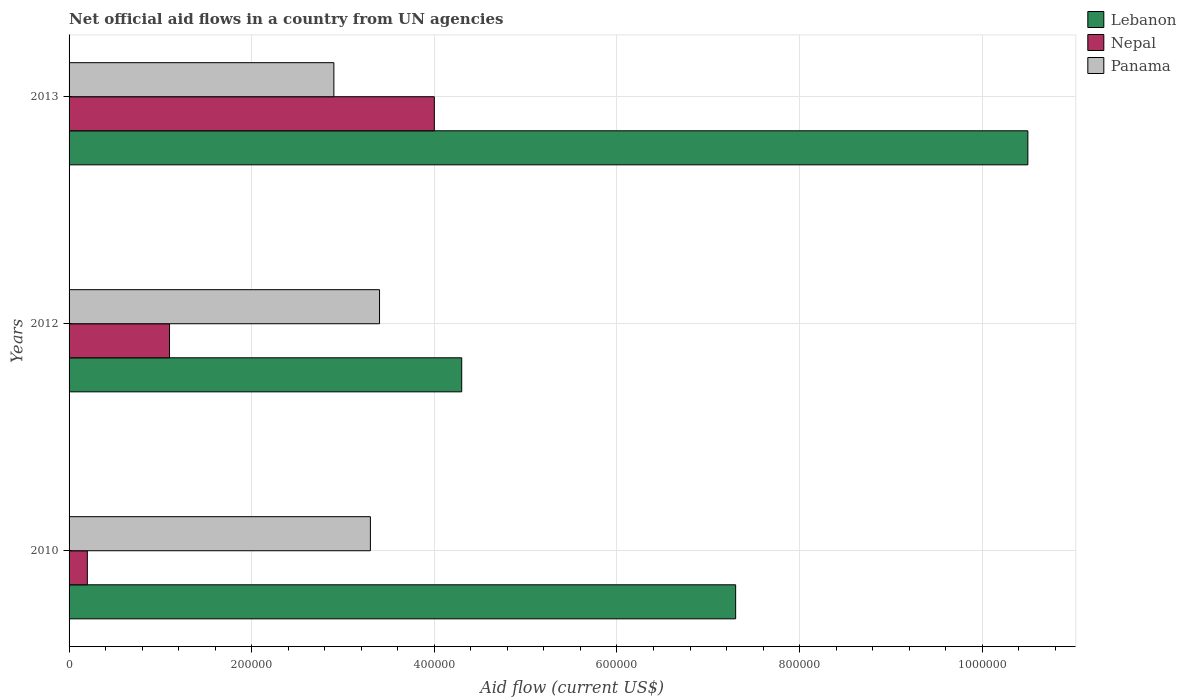How many groups of bars are there?
Give a very brief answer. 3. Are the number of bars per tick equal to the number of legend labels?
Your answer should be compact. Yes. How many bars are there on the 2nd tick from the bottom?
Offer a terse response. 3. What is the label of the 1st group of bars from the top?
Provide a short and direct response. 2013. Across all years, what is the maximum net official aid flow in Panama?
Provide a short and direct response. 3.40e+05. In which year was the net official aid flow in Nepal minimum?
Offer a terse response. 2010. What is the total net official aid flow in Nepal in the graph?
Ensure brevity in your answer.  5.30e+05. What is the difference between the net official aid flow in Panama in 2010 and that in 2012?
Provide a succinct answer. -10000. What is the difference between the net official aid flow in Nepal in 2010 and the net official aid flow in Lebanon in 2012?
Make the answer very short. -4.10e+05. What is the average net official aid flow in Nepal per year?
Provide a short and direct response. 1.77e+05. In the year 2013, what is the difference between the net official aid flow in Nepal and net official aid flow in Lebanon?
Your answer should be very brief. -6.50e+05. What is the ratio of the net official aid flow in Lebanon in 2010 to that in 2013?
Keep it short and to the point. 0.7. Is the difference between the net official aid flow in Nepal in 2010 and 2012 greater than the difference between the net official aid flow in Lebanon in 2010 and 2012?
Your response must be concise. No. What is the difference between the highest and the second highest net official aid flow in Lebanon?
Offer a very short reply. 3.20e+05. In how many years, is the net official aid flow in Panama greater than the average net official aid flow in Panama taken over all years?
Keep it short and to the point. 2. What does the 3rd bar from the top in 2010 represents?
Provide a succinct answer. Lebanon. What does the 2nd bar from the bottom in 2012 represents?
Offer a very short reply. Nepal. What is the difference between two consecutive major ticks on the X-axis?
Provide a short and direct response. 2.00e+05. Where does the legend appear in the graph?
Give a very brief answer. Top right. What is the title of the graph?
Keep it short and to the point. Net official aid flows in a country from UN agencies. Does "Denmark" appear as one of the legend labels in the graph?
Offer a terse response. No. What is the label or title of the X-axis?
Provide a short and direct response. Aid flow (current US$). What is the label or title of the Y-axis?
Offer a very short reply. Years. What is the Aid flow (current US$) of Lebanon in 2010?
Ensure brevity in your answer.  7.30e+05. What is the Aid flow (current US$) of Nepal in 2010?
Offer a terse response. 2.00e+04. What is the Aid flow (current US$) of Lebanon in 2012?
Provide a short and direct response. 4.30e+05. What is the Aid flow (current US$) in Nepal in 2012?
Give a very brief answer. 1.10e+05. What is the Aid flow (current US$) in Panama in 2012?
Offer a very short reply. 3.40e+05. What is the Aid flow (current US$) of Lebanon in 2013?
Your answer should be very brief. 1.05e+06. What is the Aid flow (current US$) of Nepal in 2013?
Make the answer very short. 4.00e+05. What is the Aid flow (current US$) of Panama in 2013?
Ensure brevity in your answer.  2.90e+05. Across all years, what is the maximum Aid flow (current US$) of Lebanon?
Offer a very short reply. 1.05e+06. Across all years, what is the maximum Aid flow (current US$) of Nepal?
Offer a terse response. 4.00e+05. Across all years, what is the minimum Aid flow (current US$) of Nepal?
Your response must be concise. 2.00e+04. Across all years, what is the minimum Aid flow (current US$) of Panama?
Provide a short and direct response. 2.90e+05. What is the total Aid flow (current US$) in Lebanon in the graph?
Your response must be concise. 2.21e+06. What is the total Aid flow (current US$) in Nepal in the graph?
Your answer should be compact. 5.30e+05. What is the total Aid flow (current US$) of Panama in the graph?
Ensure brevity in your answer.  9.60e+05. What is the difference between the Aid flow (current US$) in Lebanon in 2010 and that in 2012?
Your response must be concise. 3.00e+05. What is the difference between the Aid flow (current US$) in Panama in 2010 and that in 2012?
Your answer should be very brief. -10000. What is the difference between the Aid flow (current US$) of Lebanon in 2010 and that in 2013?
Make the answer very short. -3.20e+05. What is the difference between the Aid flow (current US$) of Nepal in 2010 and that in 2013?
Keep it short and to the point. -3.80e+05. What is the difference between the Aid flow (current US$) of Lebanon in 2012 and that in 2013?
Offer a terse response. -6.20e+05. What is the difference between the Aid flow (current US$) of Panama in 2012 and that in 2013?
Make the answer very short. 5.00e+04. What is the difference between the Aid flow (current US$) in Lebanon in 2010 and the Aid flow (current US$) in Nepal in 2012?
Keep it short and to the point. 6.20e+05. What is the difference between the Aid flow (current US$) of Lebanon in 2010 and the Aid flow (current US$) of Panama in 2012?
Make the answer very short. 3.90e+05. What is the difference between the Aid flow (current US$) in Nepal in 2010 and the Aid flow (current US$) in Panama in 2012?
Your answer should be compact. -3.20e+05. What is the difference between the Aid flow (current US$) in Lebanon in 2010 and the Aid flow (current US$) in Nepal in 2013?
Ensure brevity in your answer.  3.30e+05. What is the difference between the Aid flow (current US$) of Lebanon in 2012 and the Aid flow (current US$) of Nepal in 2013?
Provide a succinct answer. 3.00e+04. What is the average Aid flow (current US$) in Lebanon per year?
Provide a succinct answer. 7.37e+05. What is the average Aid flow (current US$) of Nepal per year?
Your response must be concise. 1.77e+05. What is the average Aid flow (current US$) of Panama per year?
Your answer should be very brief. 3.20e+05. In the year 2010, what is the difference between the Aid flow (current US$) in Lebanon and Aid flow (current US$) in Nepal?
Provide a succinct answer. 7.10e+05. In the year 2010, what is the difference between the Aid flow (current US$) of Lebanon and Aid flow (current US$) of Panama?
Give a very brief answer. 4.00e+05. In the year 2010, what is the difference between the Aid flow (current US$) of Nepal and Aid flow (current US$) of Panama?
Make the answer very short. -3.10e+05. In the year 2012, what is the difference between the Aid flow (current US$) in Lebanon and Aid flow (current US$) in Nepal?
Provide a succinct answer. 3.20e+05. In the year 2012, what is the difference between the Aid flow (current US$) in Lebanon and Aid flow (current US$) in Panama?
Offer a terse response. 9.00e+04. In the year 2013, what is the difference between the Aid flow (current US$) in Lebanon and Aid flow (current US$) in Nepal?
Offer a terse response. 6.50e+05. In the year 2013, what is the difference between the Aid flow (current US$) in Lebanon and Aid flow (current US$) in Panama?
Your answer should be very brief. 7.60e+05. In the year 2013, what is the difference between the Aid flow (current US$) in Nepal and Aid flow (current US$) in Panama?
Ensure brevity in your answer.  1.10e+05. What is the ratio of the Aid flow (current US$) in Lebanon in 2010 to that in 2012?
Give a very brief answer. 1.7. What is the ratio of the Aid flow (current US$) in Nepal in 2010 to that in 2012?
Make the answer very short. 0.18. What is the ratio of the Aid flow (current US$) of Panama in 2010 to that in 2012?
Ensure brevity in your answer.  0.97. What is the ratio of the Aid flow (current US$) of Lebanon in 2010 to that in 2013?
Ensure brevity in your answer.  0.7. What is the ratio of the Aid flow (current US$) of Nepal in 2010 to that in 2013?
Keep it short and to the point. 0.05. What is the ratio of the Aid flow (current US$) of Panama in 2010 to that in 2013?
Offer a terse response. 1.14. What is the ratio of the Aid flow (current US$) of Lebanon in 2012 to that in 2013?
Offer a very short reply. 0.41. What is the ratio of the Aid flow (current US$) of Nepal in 2012 to that in 2013?
Keep it short and to the point. 0.28. What is the ratio of the Aid flow (current US$) in Panama in 2012 to that in 2013?
Keep it short and to the point. 1.17. What is the difference between the highest and the second highest Aid flow (current US$) in Lebanon?
Keep it short and to the point. 3.20e+05. What is the difference between the highest and the lowest Aid flow (current US$) of Lebanon?
Your response must be concise. 6.20e+05. What is the difference between the highest and the lowest Aid flow (current US$) in Panama?
Provide a succinct answer. 5.00e+04. 